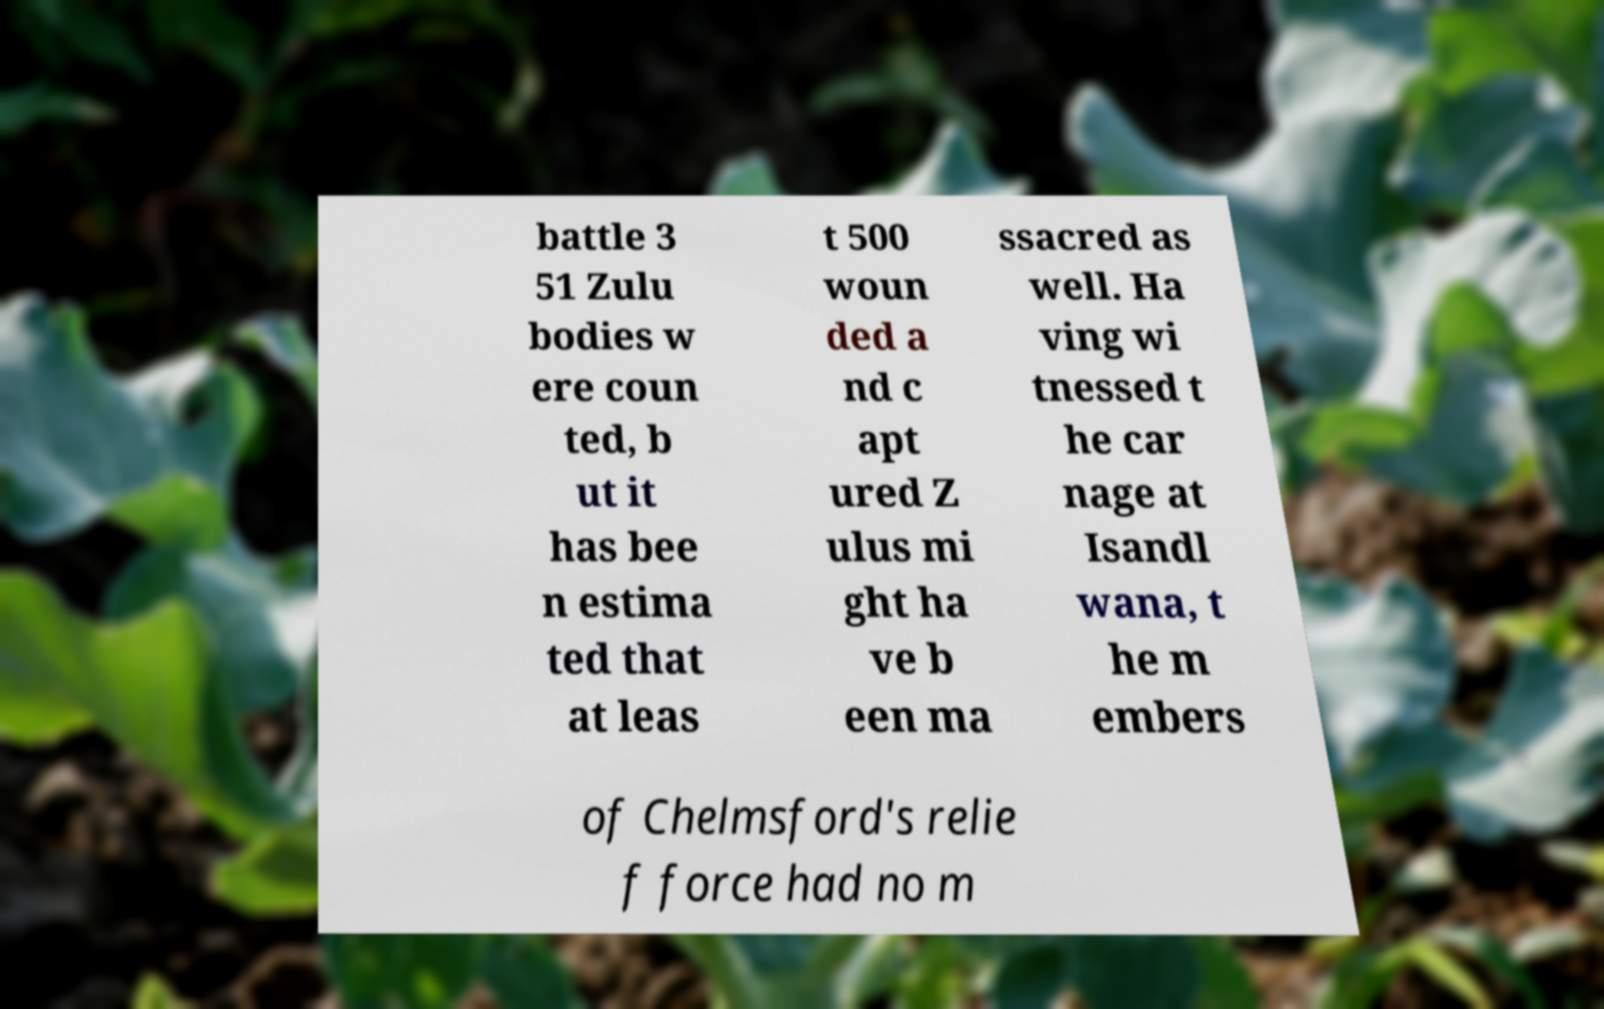For documentation purposes, I need the text within this image transcribed. Could you provide that? battle 3 51 Zulu bodies w ere coun ted, b ut it has bee n estima ted that at leas t 500 woun ded a nd c apt ured Z ulus mi ght ha ve b een ma ssacred as well. Ha ving wi tnessed t he car nage at Isandl wana, t he m embers of Chelmsford's relie f force had no m 